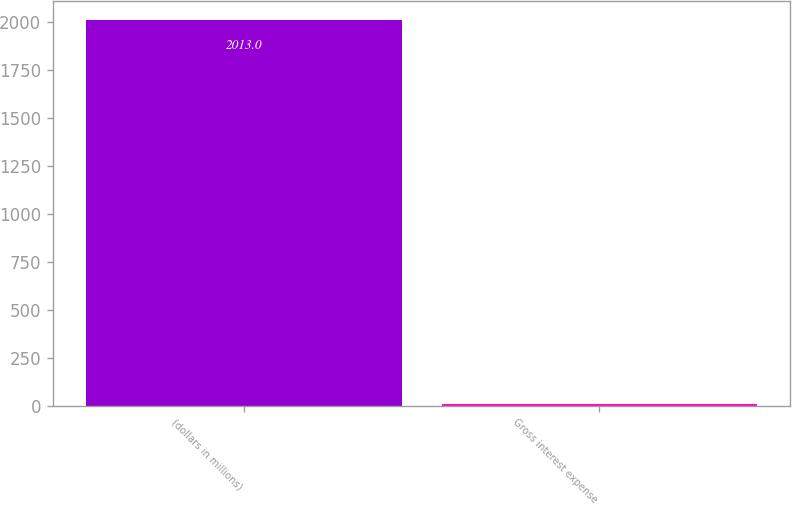Convert chart to OTSL. <chart><loc_0><loc_0><loc_500><loc_500><bar_chart><fcel>(dollars in millions)<fcel>Gross interest expense<nl><fcel>2013<fcel>9.9<nl></chart> 